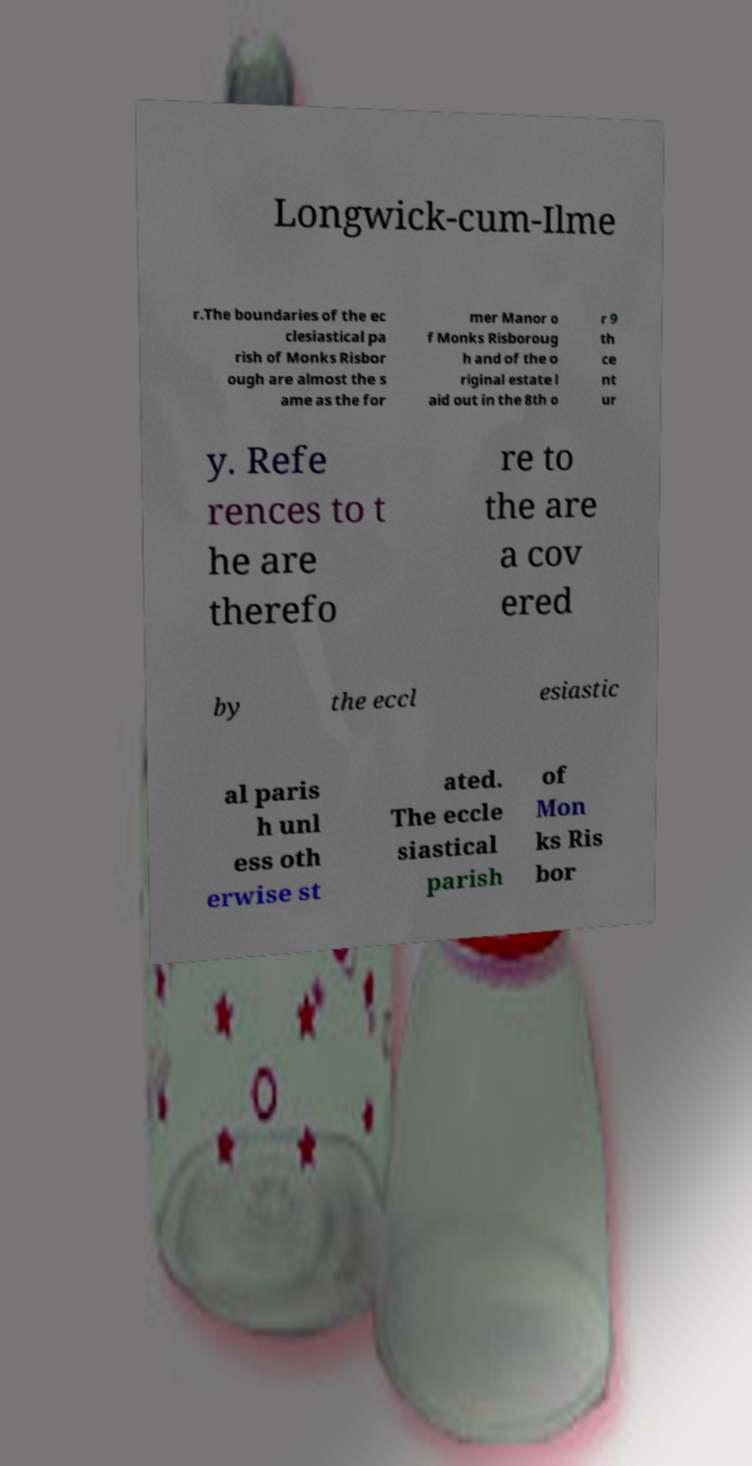Could you assist in decoding the text presented in this image and type it out clearly? Longwick-cum-Ilme r.The boundaries of the ec clesiastical pa rish of Monks Risbor ough are almost the s ame as the for mer Manor o f Monks Risboroug h and of the o riginal estate l aid out in the 8th o r 9 th ce nt ur y. Refe rences to t he are therefo re to the are a cov ered by the eccl esiastic al paris h unl ess oth erwise st ated. The eccle siastical parish of Mon ks Ris bor 